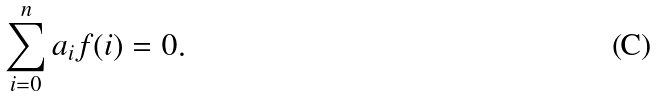<formula> <loc_0><loc_0><loc_500><loc_500>\sum _ { i = 0 } ^ { n } a _ { i } f ( i ) = 0 .</formula> 